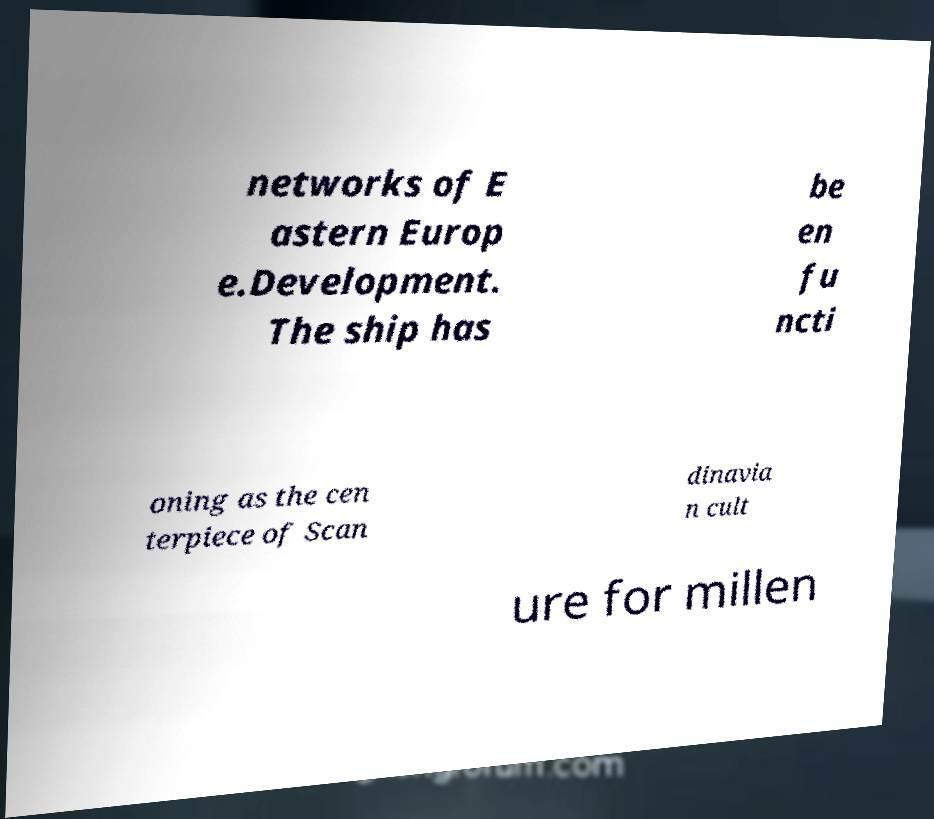Please read and relay the text visible in this image. What does it say? networks of E astern Europ e.Development. The ship has be en fu ncti oning as the cen terpiece of Scan dinavia n cult ure for millen 